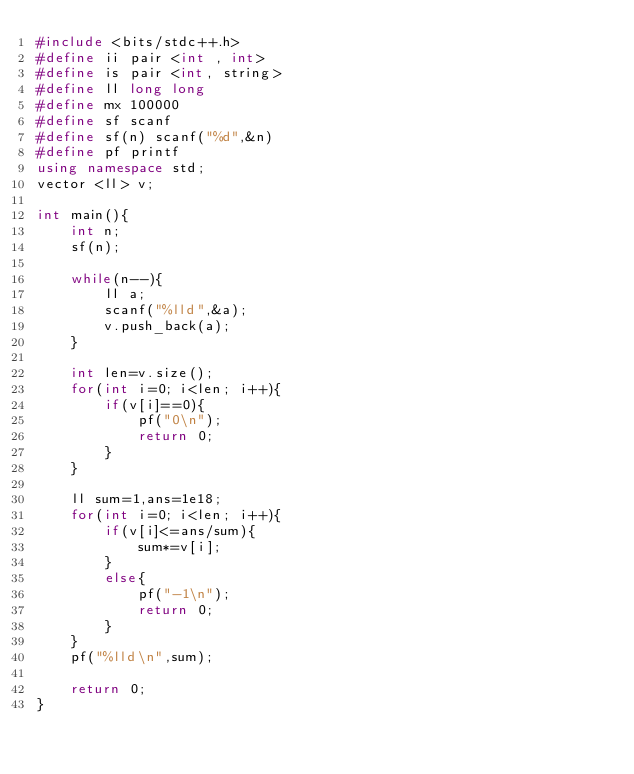Convert code to text. <code><loc_0><loc_0><loc_500><loc_500><_C++_>#include <bits/stdc++.h>
#define ii pair <int , int>
#define is pair <int, string>
#define ll long long
#define mx 100000
#define sf scanf
#define sf(n) scanf("%d",&n)
#define pf printf
using namespace std;
vector <ll> v;

int main(){
    int n;
    sf(n);

    while(n--){
        ll a;
        scanf("%lld",&a);
        v.push_back(a);
    }

    int len=v.size();
    for(int i=0; i<len; i++){
        if(v[i]==0){
            pf("0\n");
            return 0;
        }
    }

    ll sum=1,ans=1e18;
    for(int i=0; i<len; i++){
        if(v[i]<=ans/sum){
            sum*=v[i];
        }
        else{
            pf("-1\n");
            return 0;
        }
    }
    pf("%lld\n",sum);

    return 0;
}
</code> 